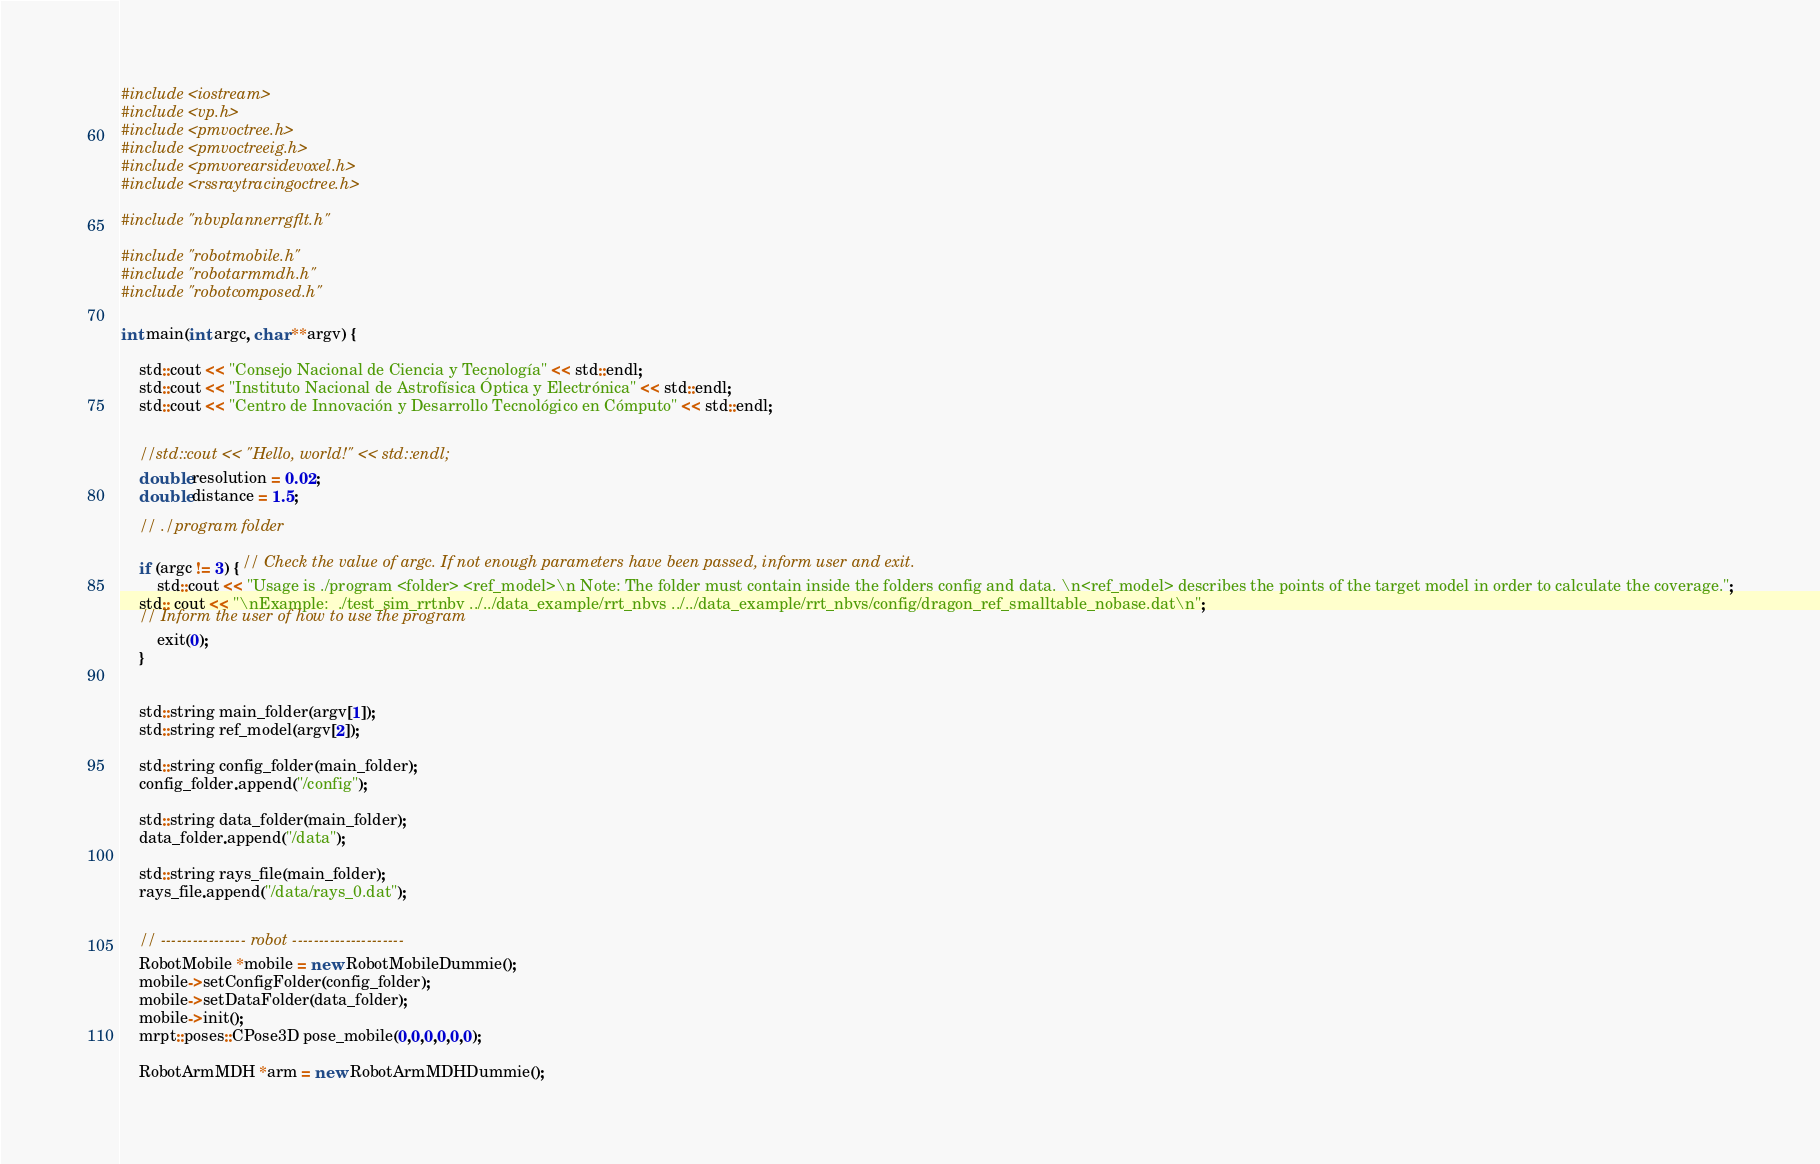Convert code to text. <code><loc_0><loc_0><loc_500><loc_500><_C++_>#include <iostream>
#include <vp.h>
#include <pmvoctree.h>
#include <pmvoctreeig.h>
#include <pmvorearsidevoxel.h>
#include <rssraytracingoctree.h>

#include "nbvplannerrgflt.h"

#include "robotmobile.h"
#include "robotarmmdh.h"
#include "robotcomposed.h"

int main(int argc, char **argv) {
    
    std::cout << "Consejo Nacional de Ciencia y Tecnología" << std::endl;
    std::cout << "Instituto Nacional de Astrofísica Óptica y Electrónica" << std::endl;
    std::cout << "Centro de Innovación y Desarrollo Tecnológico en Cómputo" << std::endl;
    
  
    //std::cout << "Hello, world!" << std::endl;
    double resolution = 0.02;
    double distance = 1.5;
    
    // ./program folder 
    
    if (argc != 3) { // Check the value of argc. If not enough parameters have been passed, inform user and exit.
        std::cout << "Usage is ./program <folder> <ref_model>\n Note: The folder must contain inside the folders config and data. \n<ref_model> describes the points of the target model in order to calculate the coverage.";
	std:: cout << "\nExample:  ./test_sim_rrtnbv ../../data_example/rrt_nbvs ../../data_example/rrt_nbvs/config/dragon_ref_smalltable_nobase.dat\n"; 
	// Inform the user of how to use the program
        exit(0);
    } 
    
    
    std::string main_folder(argv[1]);
    std::string ref_model(argv[2]);
    
    std::string config_folder(main_folder);
    config_folder.append("/config");
    
    std::string data_folder(main_folder);
    data_folder.append("/data");
    
    std::string rays_file(main_folder);
    rays_file.append("/data/rays_0.dat");
    
   
    // ---------------- robot ---------------------
    RobotMobile *mobile = new RobotMobileDummie();
    mobile->setConfigFolder(config_folder);
    mobile->setDataFolder(data_folder);
    mobile->init();
    mrpt::poses::CPose3D pose_mobile(0,0,0,0,0,0);
    
    RobotArmMDH *arm = new RobotArmMDHDummie();</code> 